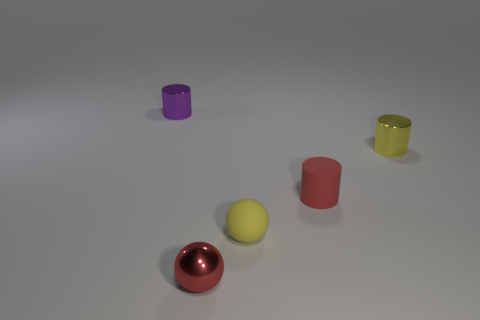Is the size of the red cylinder the same as the shiny object that is on the left side of the red shiny sphere?
Your response must be concise. Yes. There is a tiny red object in front of the rubber cylinder; what is its shape?
Your answer should be compact. Sphere. Is there anything else that has the same shape as the tiny red matte thing?
Ensure brevity in your answer.  Yes. Are there any cylinders?
Keep it short and to the point. Yes. Does the yellow thing to the right of the yellow sphere have the same size as the object on the left side of the tiny red metallic ball?
Give a very brief answer. Yes. There is a tiny object that is both in front of the yellow metallic cylinder and on the left side of the yellow rubber object; what material is it?
Offer a very short reply. Metal. There is a tiny purple metallic cylinder; what number of tiny metallic cylinders are right of it?
Offer a very short reply. 1. Is there anything else that is the same size as the yellow sphere?
Offer a very short reply. Yes. The tiny sphere that is made of the same material as the tiny yellow cylinder is what color?
Your answer should be compact. Red. Is the red metallic object the same shape as the yellow metallic object?
Your response must be concise. No. 